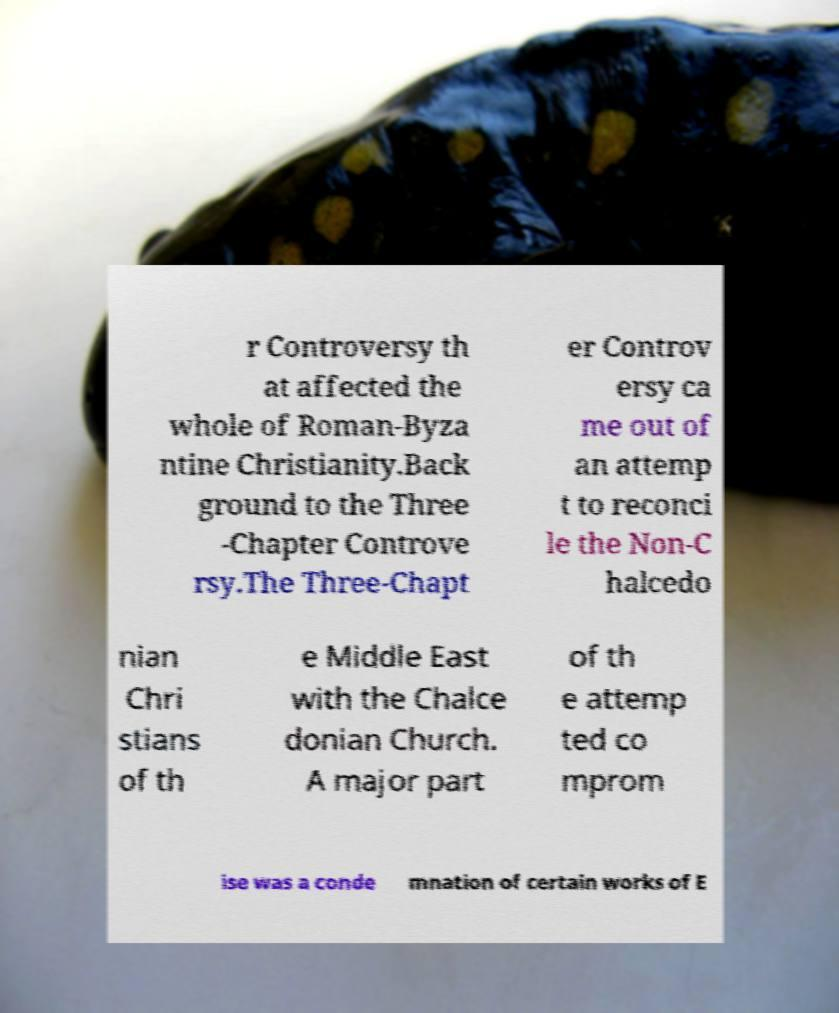Could you assist in decoding the text presented in this image and type it out clearly? r Controversy th at affected the whole of Roman-Byza ntine Christianity.Back ground to the Three -Chapter Controve rsy.The Three-Chapt er Controv ersy ca me out of an attemp t to reconci le the Non-C halcedo nian Chri stians of th e Middle East with the Chalce donian Church. A major part of th e attemp ted co mprom ise was a conde mnation of certain works of E 